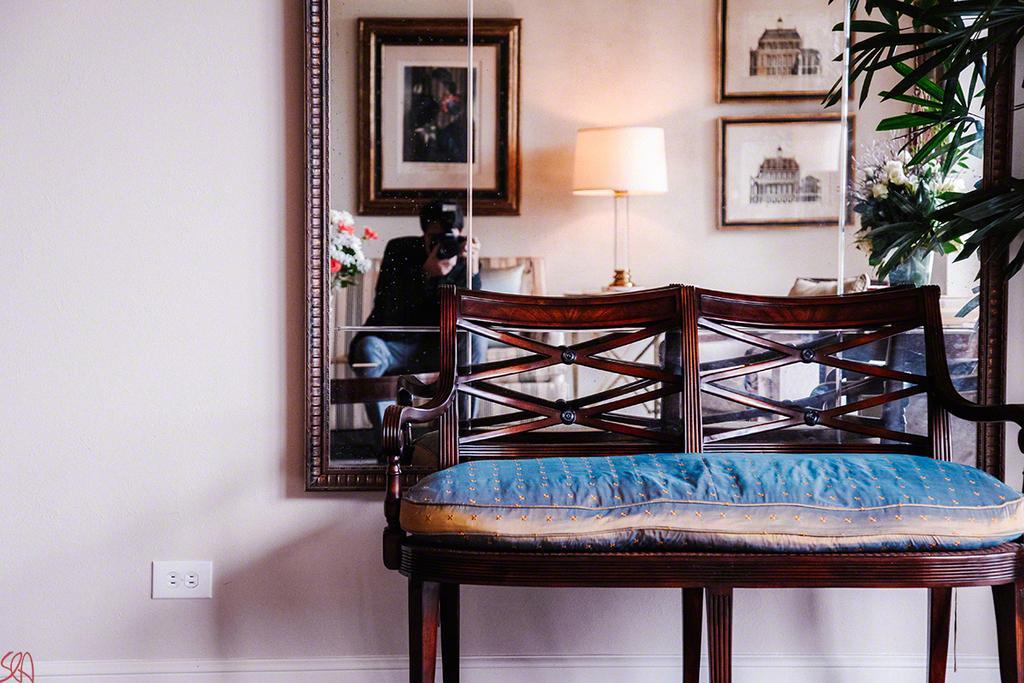Can you describe this image briefly? In this image there is a mirror on the wall, there is a plant truncated towards the right of the image, there is a chair truncated towards the right of the image, there is a cushion on the chair, there is a mirror on the wall, there are photo frames, there is a light, there is a person sitting and taking a photo, there are flowers, there is a flower vase on the surface, there is text towards the bottom of the image, there is a socket on the wall. 